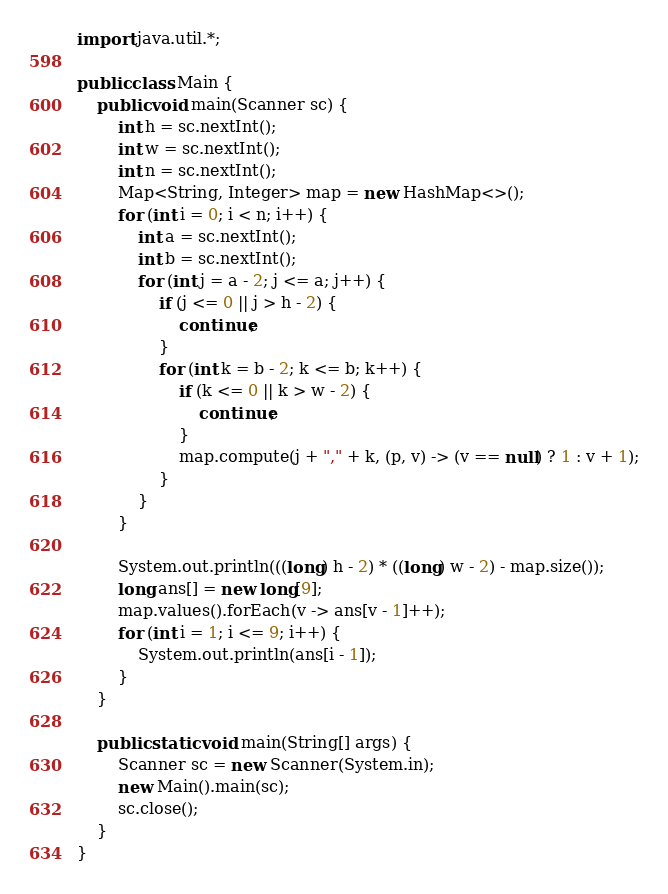<code> <loc_0><loc_0><loc_500><loc_500><_Java_>import java.util.*;

public class Main {
    public void main(Scanner sc) {
        int h = sc.nextInt();
        int w = sc.nextInt();
        int n = sc.nextInt();
        Map<String, Integer> map = new HashMap<>();
        for (int i = 0; i < n; i++) {
            int a = sc.nextInt();
            int b = sc.nextInt();
            for (int j = a - 2; j <= a; j++) {
                if (j <= 0 || j > h - 2) {
                    continue;
                }
                for (int k = b - 2; k <= b; k++) {
                    if (k <= 0 || k > w - 2) {
                        continue;
                    }
                    map.compute(j + "," + k, (p, v) -> (v == null) ? 1 : v + 1);
                }
            }
        }

        System.out.println(((long) h - 2) * ((long) w - 2) - map.size());
        long ans[] = new long[9];
        map.values().forEach(v -> ans[v - 1]++);
        for (int i = 1; i <= 9; i++) {
            System.out.println(ans[i - 1]);
        }
    }

    public static void main(String[] args) {
        Scanner sc = new Scanner(System.in);
        new Main().main(sc);
        sc.close();
    }
}
</code> 